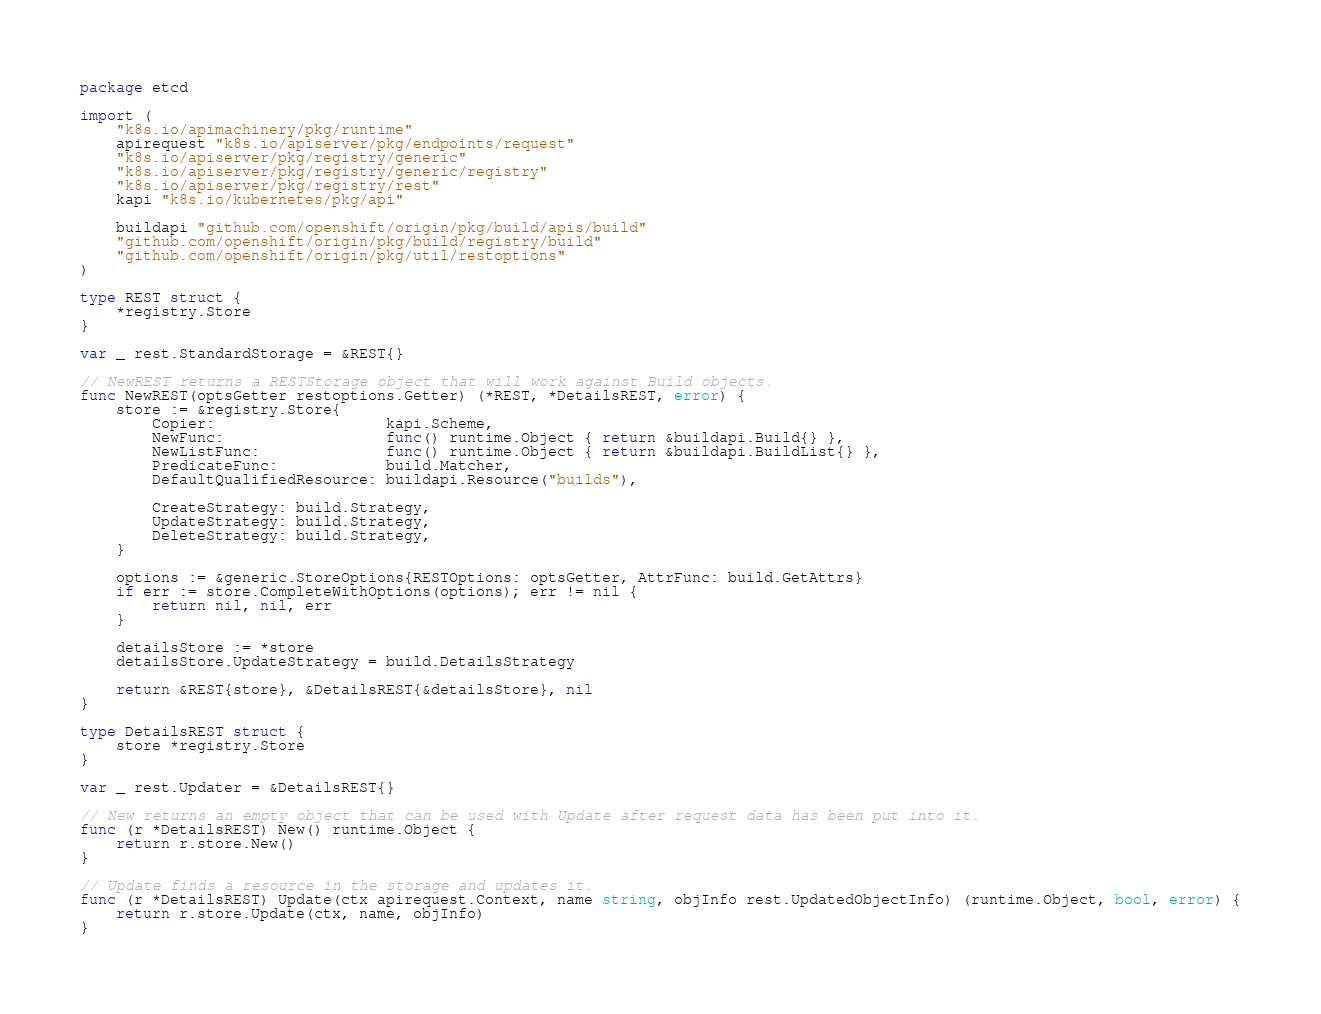<code> <loc_0><loc_0><loc_500><loc_500><_Go_>package etcd

import (
	"k8s.io/apimachinery/pkg/runtime"
	apirequest "k8s.io/apiserver/pkg/endpoints/request"
	"k8s.io/apiserver/pkg/registry/generic"
	"k8s.io/apiserver/pkg/registry/generic/registry"
	"k8s.io/apiserver/pkg/registry/rest"
	kapi "k8s.io/kubernetes/pkg/api"

	buildapi "github.com/openshift/origin/pkg/build/apis/build"
	"github.com/openshift/origin/pkg/build/registry/build"
	"github.com/openshift/origin/pkg/util/restoptions"
)

type REST struct {
	*registry.Store
}

var _ rest.StandardStorage = &REST{}

// NewREST returns a RESTStorage object that will work against Build objects.
func NewREST(optsGetter restoptions.Getter) (*REST, *DetailsREST, error) {
	store := &registry.Store{
		Copier:                   kapi.Scheme,
		NewFunc:                  func() runtime.Object { return &buildapi.Build{} },
		NewListFunc:              func() runtime.Object { return &buildapi.BuildList{} },
		PredicateFunc:            build.Matcher,
		DefaultQualifiedResource: buildapi.Resource("builds"),

		CreateStrategy: build.Strategy,
		UpdateStrategy: build.Strategy,
		DeleteStrategy: build.Strategy,
	}

	options := &generic.StoreOptions{RESTOptions: optsGetter, AttrFunc: build.GetAttrs}
	if err := store.CompleteWithOptions(options); err != nil {
		return nil, nil, err
	}

	detailsStore := *store
	detailsStore.UpdateStrategy = build.DetailsStrategy

	return &REST{store}, &DetailsREST{&detailsStore}, nil
}

type DetailsREST struct {
	store *registry.Store
}

var _ rest.Updater = &DetailsREST{}

// New returns an empty object that can be used with Update after request data has been put into it.
func (r *DetailsREST) New() runtime.Object {
	return r.store.New()
}

// Update finds a resource in the storage and updates it.
func (r *DetailsREST) Update(ctx apirequest.Context, name string, objInfo rest.UpdatedObjectInfo) (runtime.Object, bool, error) {
	return r.store.Update(ctx, name, objInfo)
}
</code> 